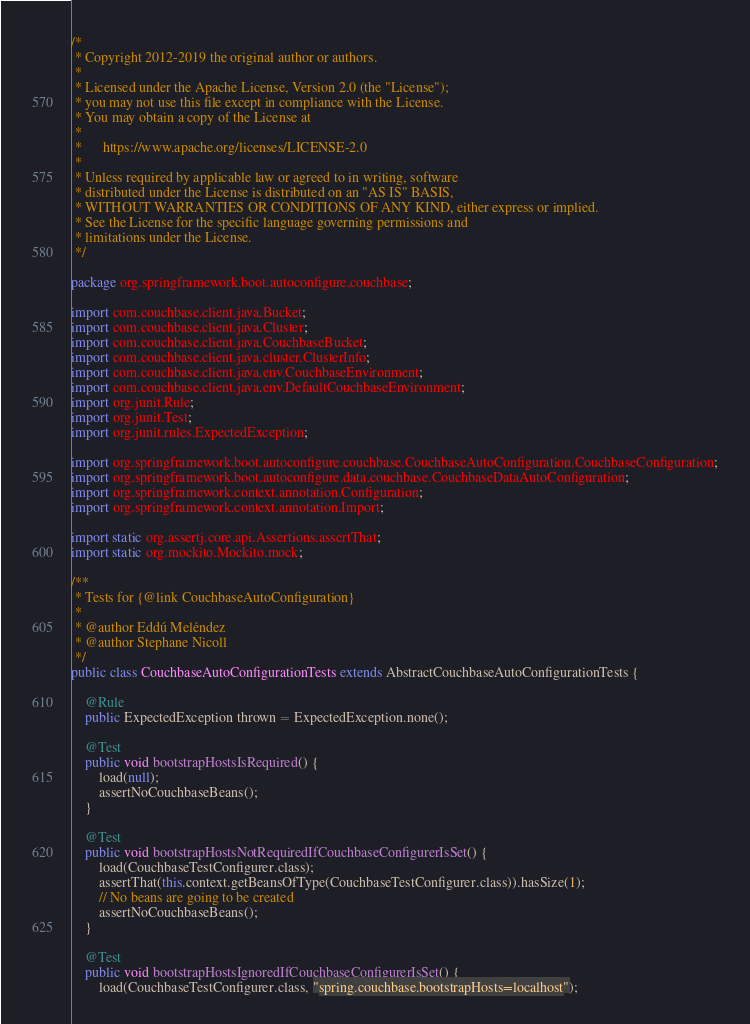Convert code to text. <code><loc_0><loc_0><loc_500><loc_500><_Java_>/*
 * Copyright 2012-2019 the original author or authors.
 *
 * Licensed under the Apache License, Version 2.0 (the "License");
 * you may not use this file except in compliance with the License.
 * You may obtain a copy of the License at
 *
 *      https://www.apache.org/licenses/LICENSE-2.0
 *
 * Unless required by applicable law or agreed to in writing, software
 * distributed under the License is distributed on an "AS IS" BASIS,
 * WITHOUT WARRANTIES OR CONDITIONS OF ANY KIND, either express or implied.
 * See the License for the specific language governing permissions and
 * limitations under the License.
 */

package org.springframework.boot.autoconfigure.couchbase;

import com.couchbase.client.java.Bucket;
import com.couchbase.client.java.Cluster;
import com.couchbase.client.java.CouchbaseBucket;
import com.couchbase.client.java.cluster.ClusterInfo;
import com.couchbase.client.java.env.CouchbaseEnvironment;
import com.couchbase.client.java.env.DefaultCouchbaseEnvironment;
import org.junit.Rule;
import org.junit.Test;
import org.junit.rules.ExpectedException;

import org.springframework.boot.autoconfigure.couchbase.CouchbaseAutoConfiguration.CouchbaseConfiguration;
import org.springframework.boot.autoconfigure.data.couchbase.CouchbaseDataAutoConfiguration;
import org.springframework.context.annotation.Configuration;
import org.springframework.context.annotation.Import;

import static org.assertj.core.api.Assertions.assertThat;
import static org.mockito.Mockito.mock;

/**
 * Tests for {@link CouchbaseAutoConfiguration}
 *
 * @author Eddú Meléndez
 * @author Stephane Nicoll
 */
public class CouchbaseAutoConfigurationTests extends AbstractCouchbaseAutoConfigurationTests {

	@Rule
	public ExpectedException thrown = ExpectedException.none();

	@Test
	public void bootstrapHostsIsRequired() {
		load(null);
		assertNoCouchbaseBeans();
	}

	@Test
	public void bootstrapHostsNotRequiredIfCouchbaseConfigurerIsSet() {
		load(CouchbaseTestConfigurer.class);
		assertThat(this.context.getBeansOfType(CouchbaseTestConfigurer.class)).hasSize(1);
		// No beans are going to be created
		assertNoCouchbaseBeans();
	}

	@Test
	public void bootstrapHostsIgnoredIfCouchbaseConfigurerIsSet() {
		load(CouchbaseTestConfigurer.class, "spring.couchbase.bootstrapHosts=localhost");</code> 